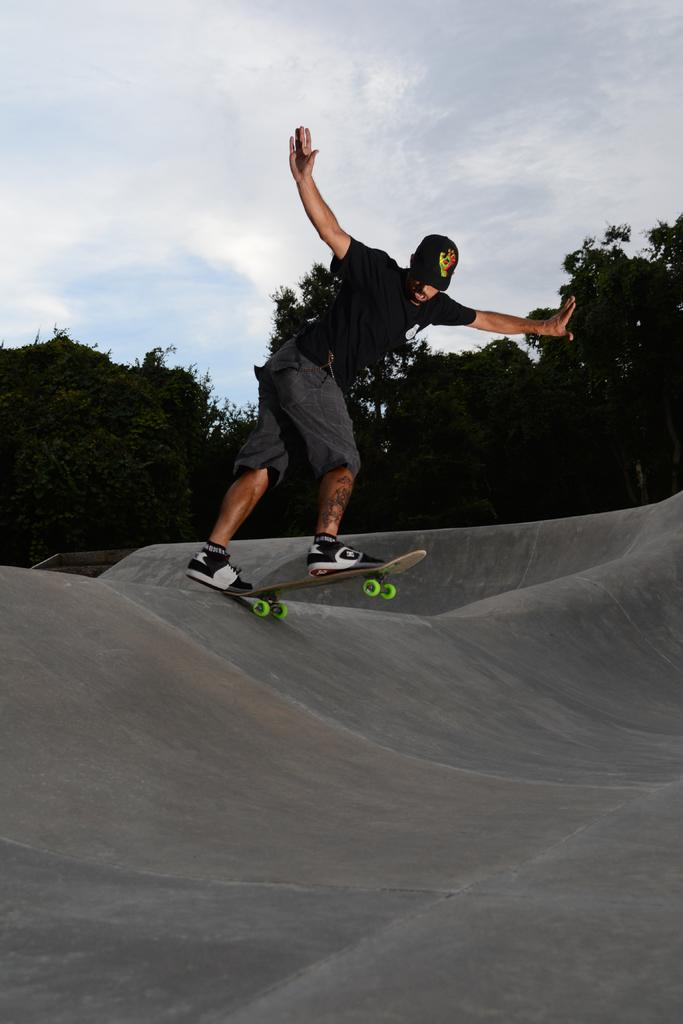What is the main subject of the image? There is a person in the image. What is the person doing in the image? The person is standing on a skateboard and skating on a slope area. What can be seen on the person's head? The person is wearing a cap. What is visible in the background of the image? There are trees in the background of the image. What is visible at the top of the image? The sky is visible at the top of the image. Where is the toothbrush located in the image? There is no toothbrush present in the image. What type of ticket can be seen in the person's hand in the image? There is no ticket visible in the person's hand in the image. 